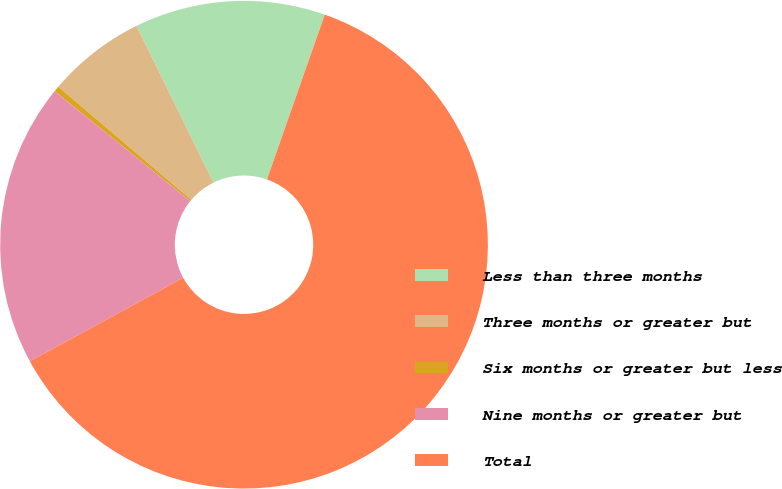Convert chart. <chart><loc_0><loc_0><loc_500><loc_500><pie_chart><fcel>Less than three months<fcel>Three months or greater but<fcel>Six months or greater but less<fcel>Nine months or greater but<fcel>Total<nl><fcel>12.64%<fcel>6.51%<fcel>0.38%<fcel>18.77%<fcel>61.69%<nl></chart> 